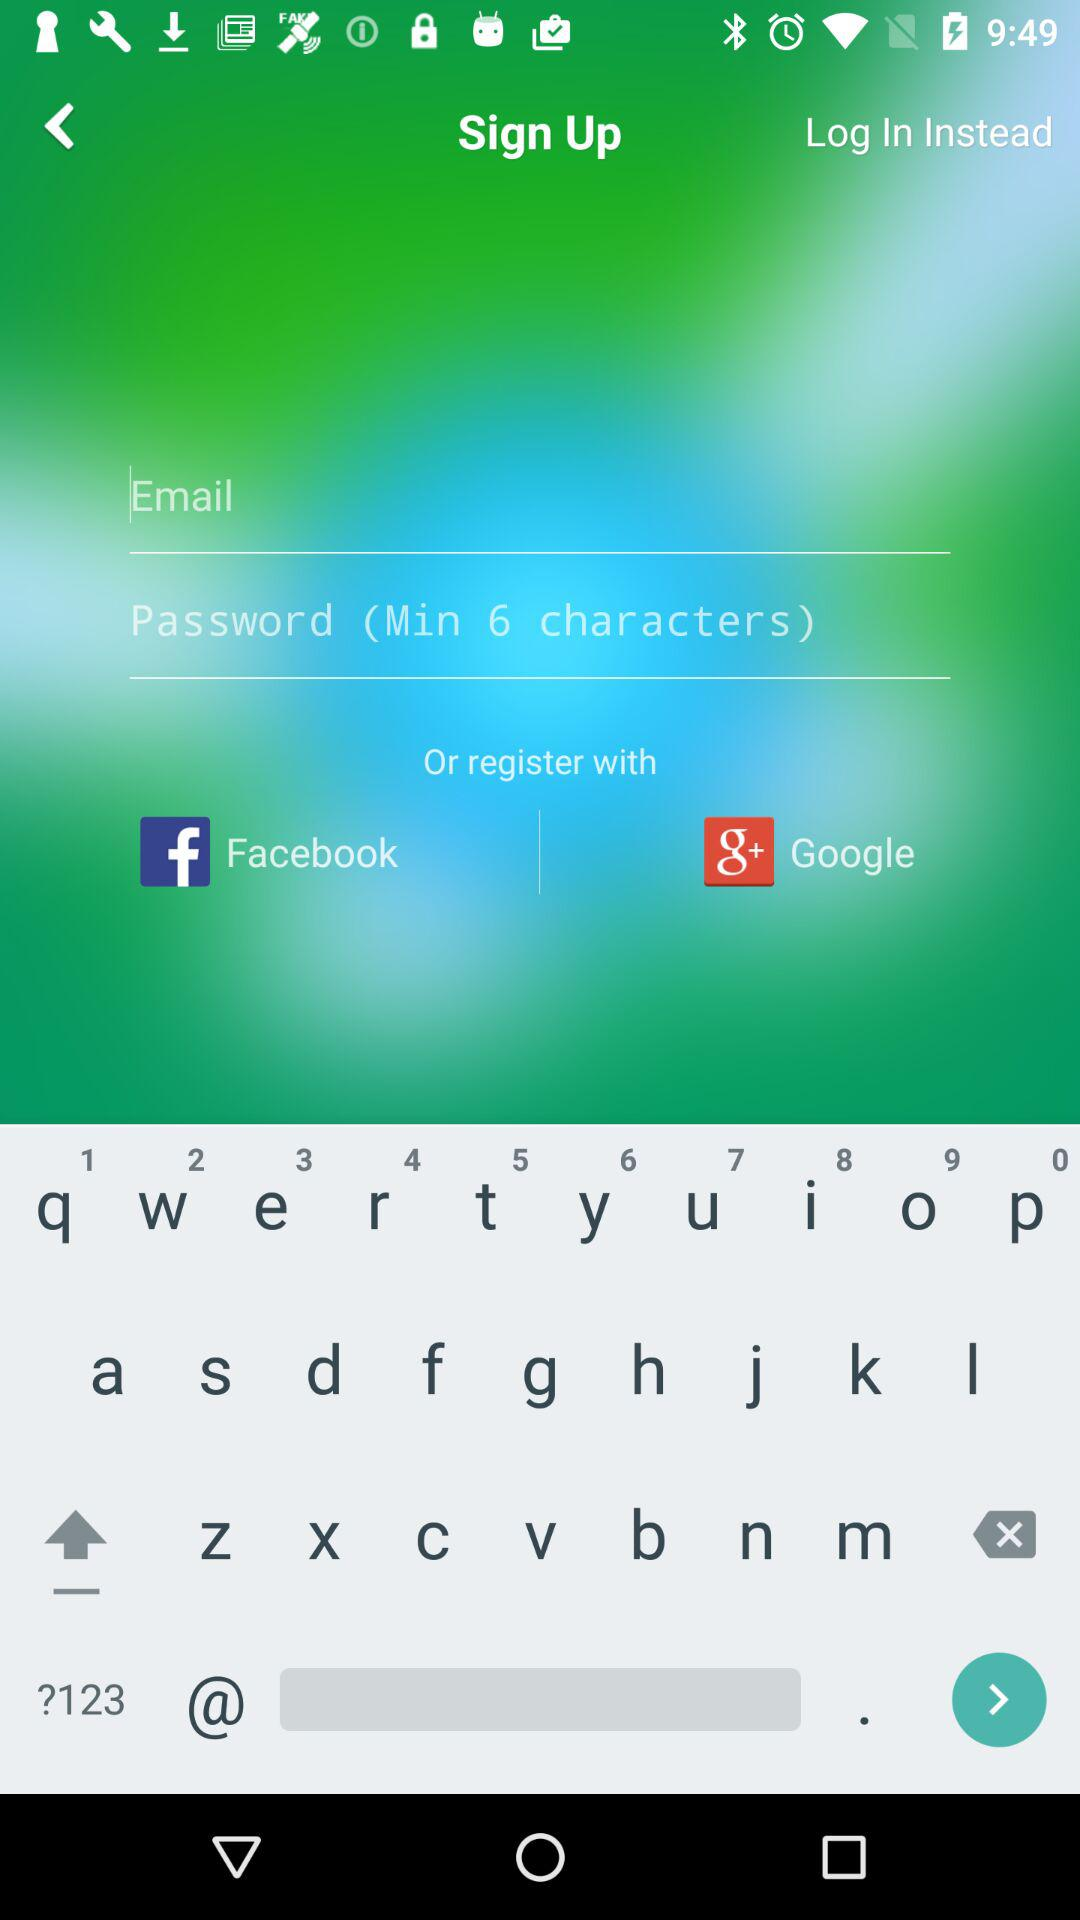What is the user's name? The user's name is Sam Brown. 